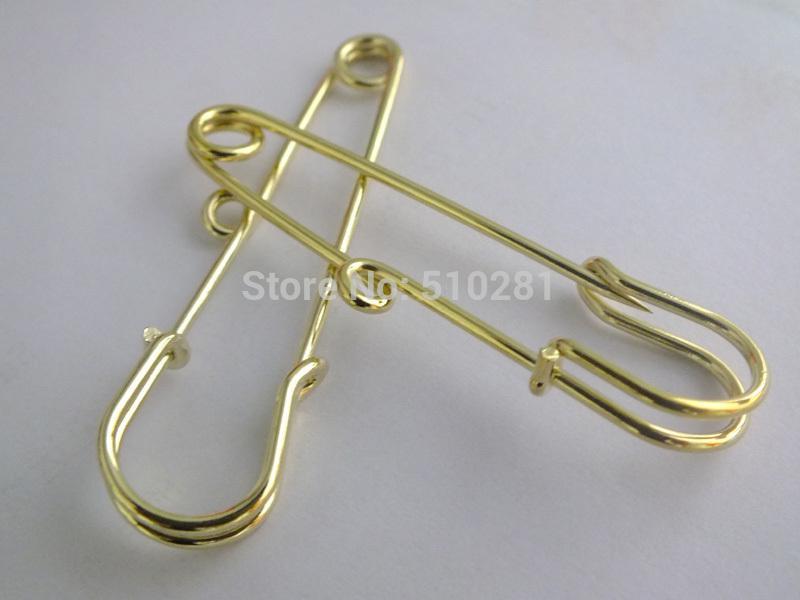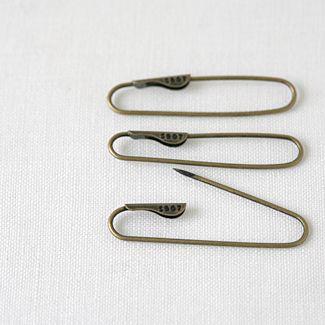The first image is the image on the left, the second image is the image on the right. Analyze the images presented: Is the assertion "one of the safety pins is open." valid? Answer yes or no. Yes. 